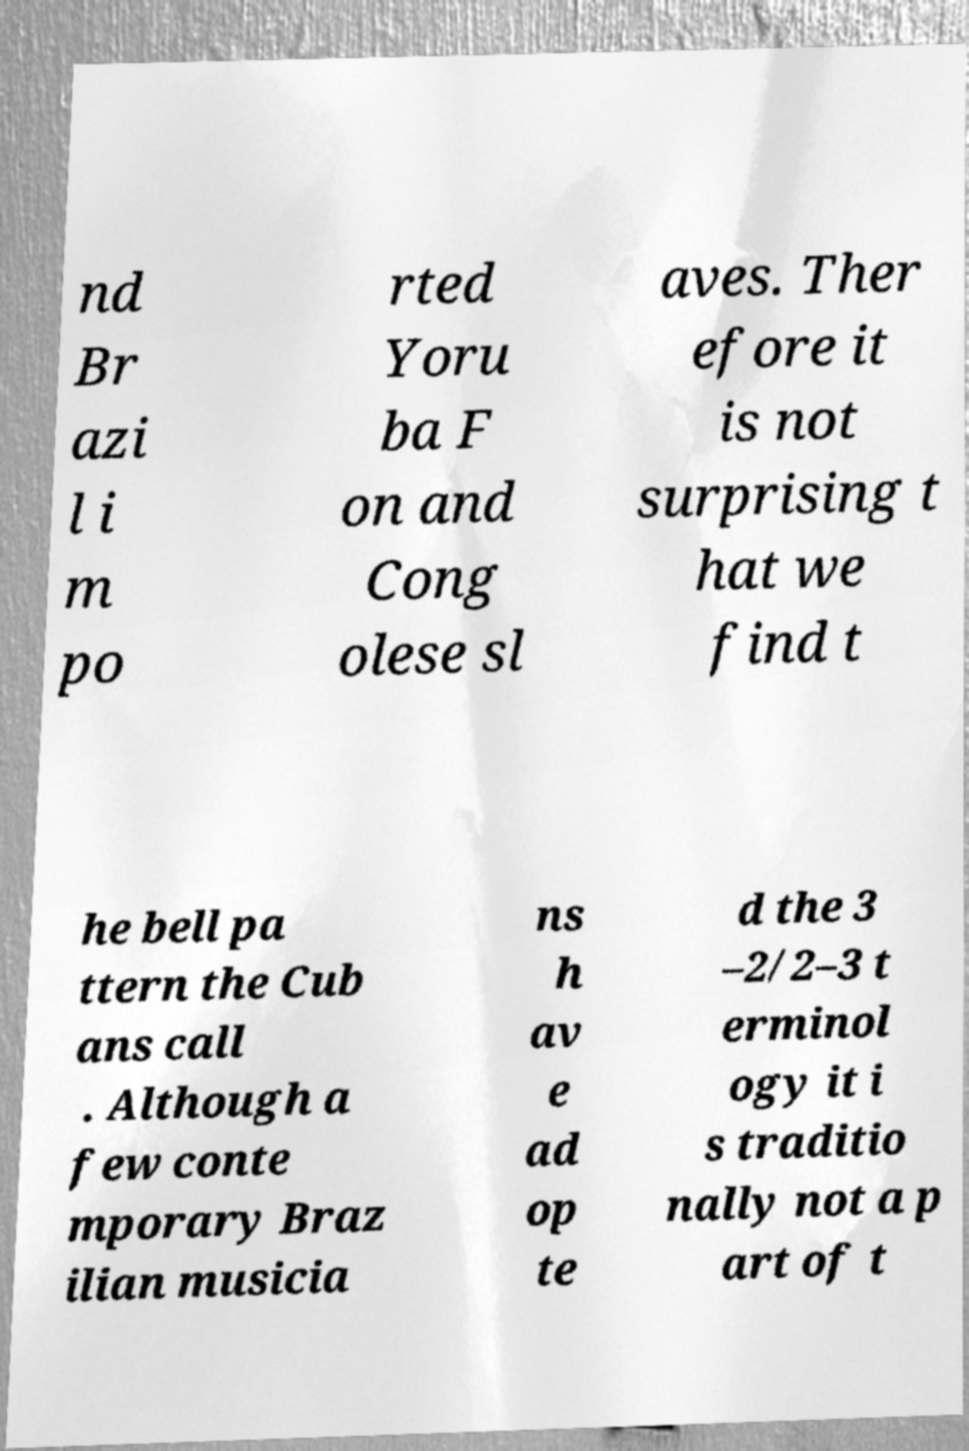I need the written content from this picture converted into text. Can you do that? nd Br azi l i m po rted Yoru ba F on and Cong olese sl aves. Ther efore it is not surprising t hat we find t he bell pa ttern the Cub ans call . Although a few conte mporary Braz ilian musicia ns h av e ad op te d the 3 –2/2–3 t erminol ogy it i s traditio nally not a p art of t 